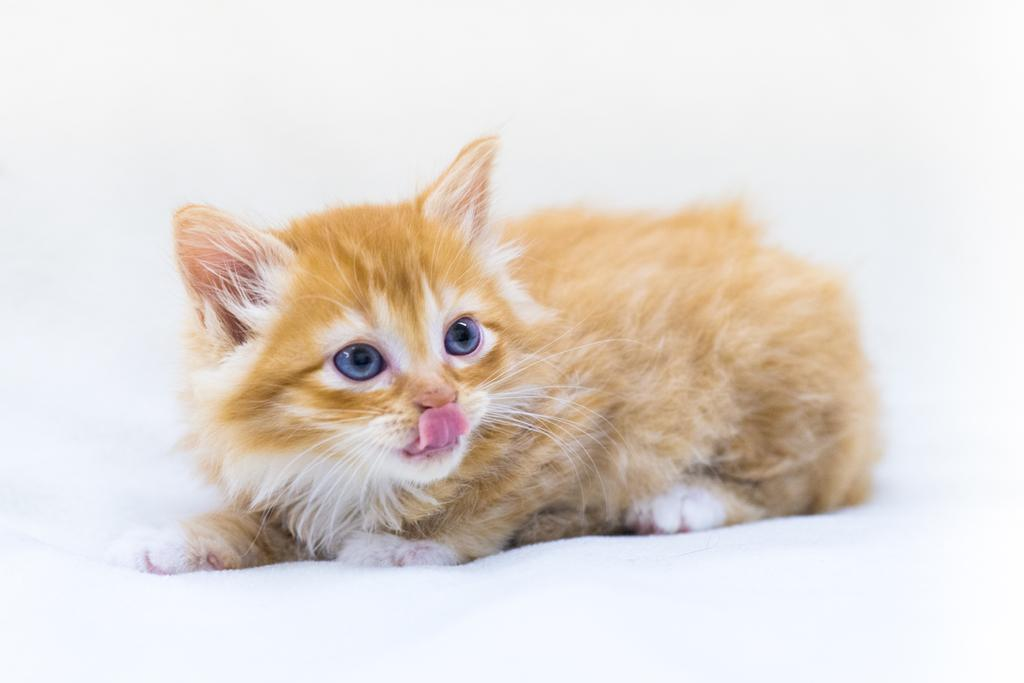What type of animal is in the image? There is a cat in the image. What colors can be seen on the cat? The cat has brown, cream, blue, and pink colors. What is the cat laying on in the image? The cat is laying on a white surface. What color is the background of the image? The background of the image is white. How does the cat help people in the image? The image does not depict the cat helping people; it simply shows the cat laying on a white surface. 